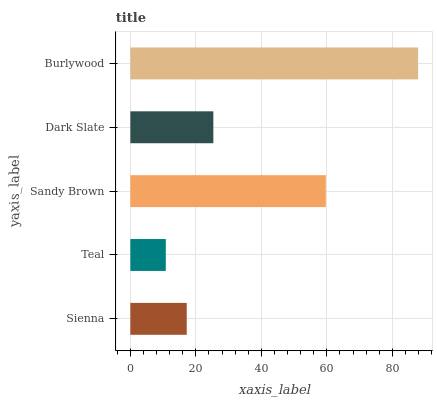Is Teal the minimum?
Answer yes or no. Yes. Is Burlywood the maximum?
Answer yes or no. Yes. Is Sandy Brown the minimum?
Answer yes or no. No. Is Sandy Brown the maximum?
Answer yes or no. No. Is Sandy Brown greater than Teal?
Answer yes or no. Yes. Is Teal less than Sandy Brown?
Answer yes or no. Yes. Is Teal greater than Sandy Brown?
Answer yes or no. No. Is Sandy Brown less than Teal?
Answer yes or no. No. Is Dark Slate the high median?
Answer yes or no. Yes. Is Dark Slate the low median?
Answer yes or no. Yes. Is Sienna the high median?
Answer yes or no. No. Is Burlywood the low median?
Answer yes or no. No. 